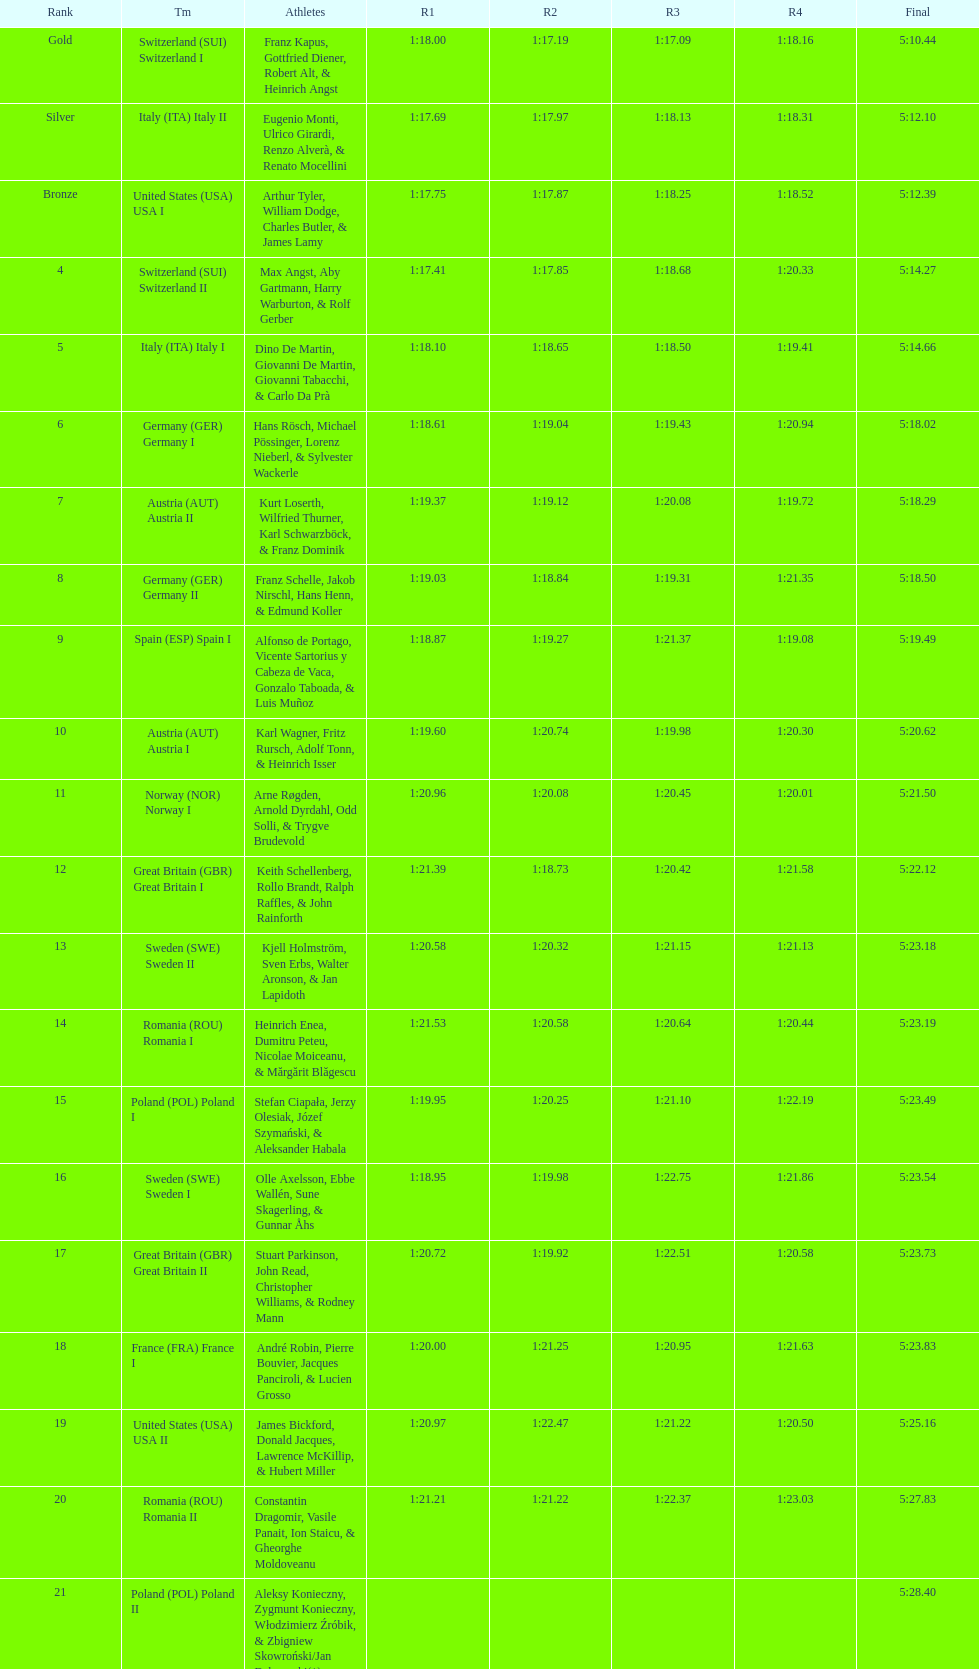Which team won the most runs? Switzerland. 